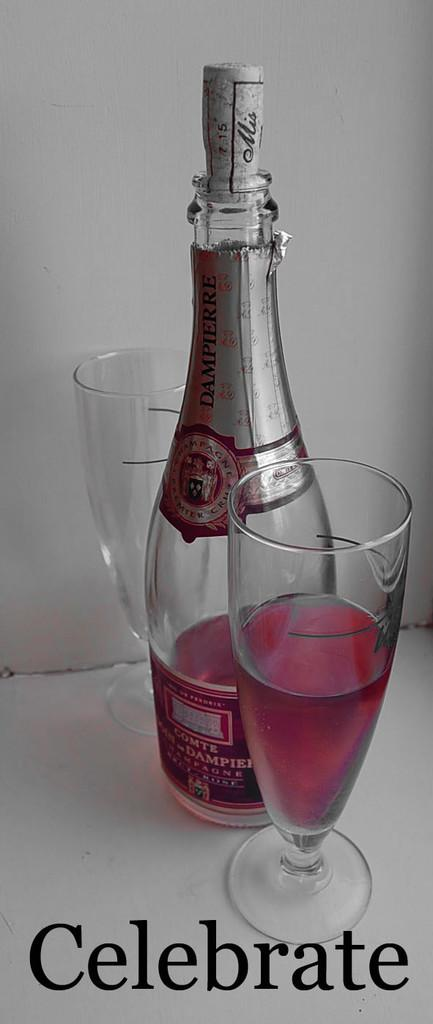<image>
Create a compact narrative representing the image presented. A bottle of champagne with two glasses with the words celebrate on the bottom of the screen 